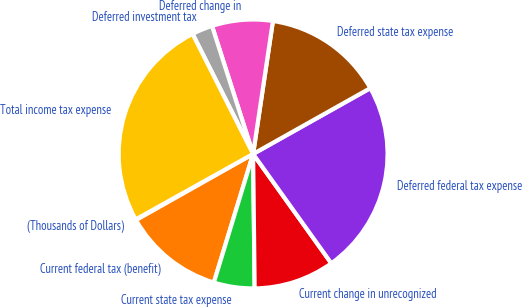Convert chart. <chart><loc_0><loc_0><loc_500><loc_500><pie_chart><fcel>(Thousands of Dollars)<fcel>Current federal tax (benefit)<fcel>Current state tax expense<fcel>Current change in unrecognized<fcel>Deferred federal tax expense<fcel>Deferred state tax expense<fcel>Deferred change in<fcel>Deferred investment tax<fcel>Total income tax expense<nl><fcel>0.09%<fcel>12.1%<fcel>4.9%<fcel>9.7%<fcel>23.26%<fcel>14.5%<fcel>7.3%<fcel>2.49%<fcel>25.66%<nl></chart> 